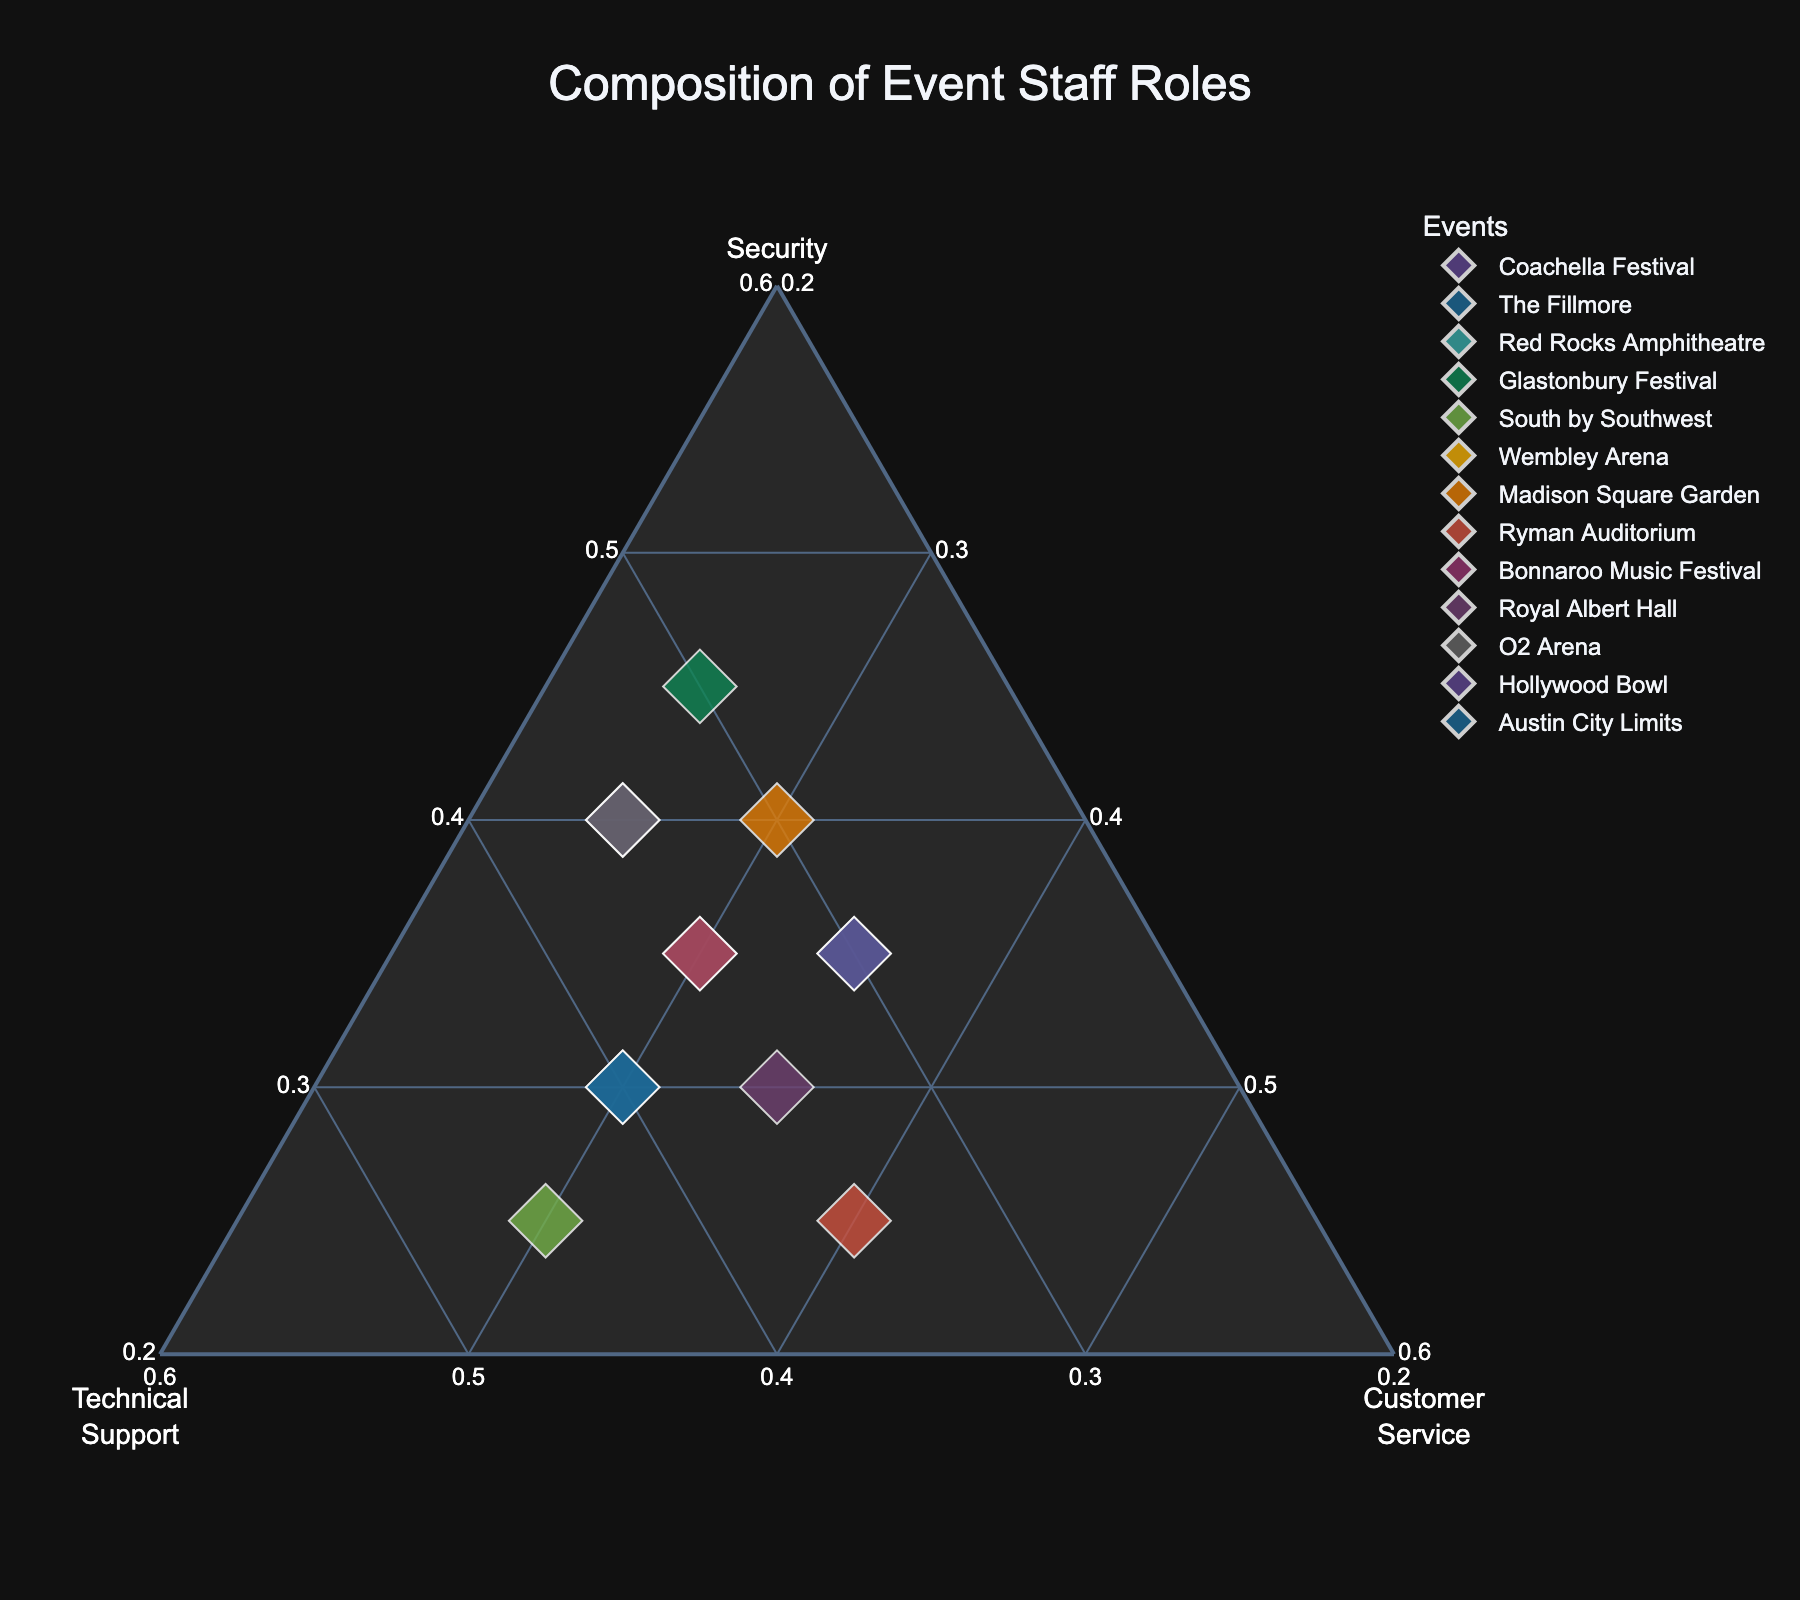How many events are represented in the ternary plot? Count the number of unique events (points) in the plot. There are distinct colored points corresponding to each event.
Answer: 13 Which event has the highest proportion of technical support staff? Identify the point closest to the Technical Support axis. This event has the highest proportion as that axis represents 100% technical support.
Answer: South by Southwest Among the events Coachella Festival and Madison Square Garden, which one prioritizes customer service more? Compare the position of each event on the Customer Service axis. The event closer to this axis has a higher proportion of customer service staff.
Answer: Madison Square Garden What are the proportions of security, technical support, and customer service at The Fillmore? Look at the coordinates of The Fillmore on the ternary plot. Each axis will give the respective proportions of security, technical support, and customer service.
Answer: Security: 30%, Technical Support: 40%, Customer Service: 30% Do any events have an equal proportion of security staff and customer service staff? Find events that lie on the bisector line between the Security and Customer Service axes. These points represent equal proportions of security and customer service staff.
Answer: Red Rocks Amphitheatre, Hollywood Bowl Which event has the most balanced distribution among security, technical support, and customer service? Look for the point closest to the center of the ternary plot, as it indicates a balanced distribution among all three roles.
Answer: Ryman Auditorium What is the average proportion of security staff across all events? Sum the percentages of security staff for all events and then divide by the number of events. Calculation: (40+30+35+45+25+35+40+25+35+30+40+35+30) / 13 = 34.23%
Answer: 34.23% Which two events have the highest combined proportion of technical support staff? Identify the two points closest to the Technical Support axis and sum their proportions. The two highest points represent the combined maximum proportion.
Answer: South by Southwest and Austin City Limits Is there any event where the proportion of customer service staff is higher than both security and technical support staff? Look for points where the Customer Service proportion is higher than the other two axes.
Answer: Ryman Auditorium Between Wembley Arena and Glastonbury Festival, which one has a higher proportion of security staff? Compare the positions of Wembley Arena and Glastonbury Festival on the Security axis. The one closer to the axis has a higher proportion of security staff.
Answer: Glastonbury Festival 